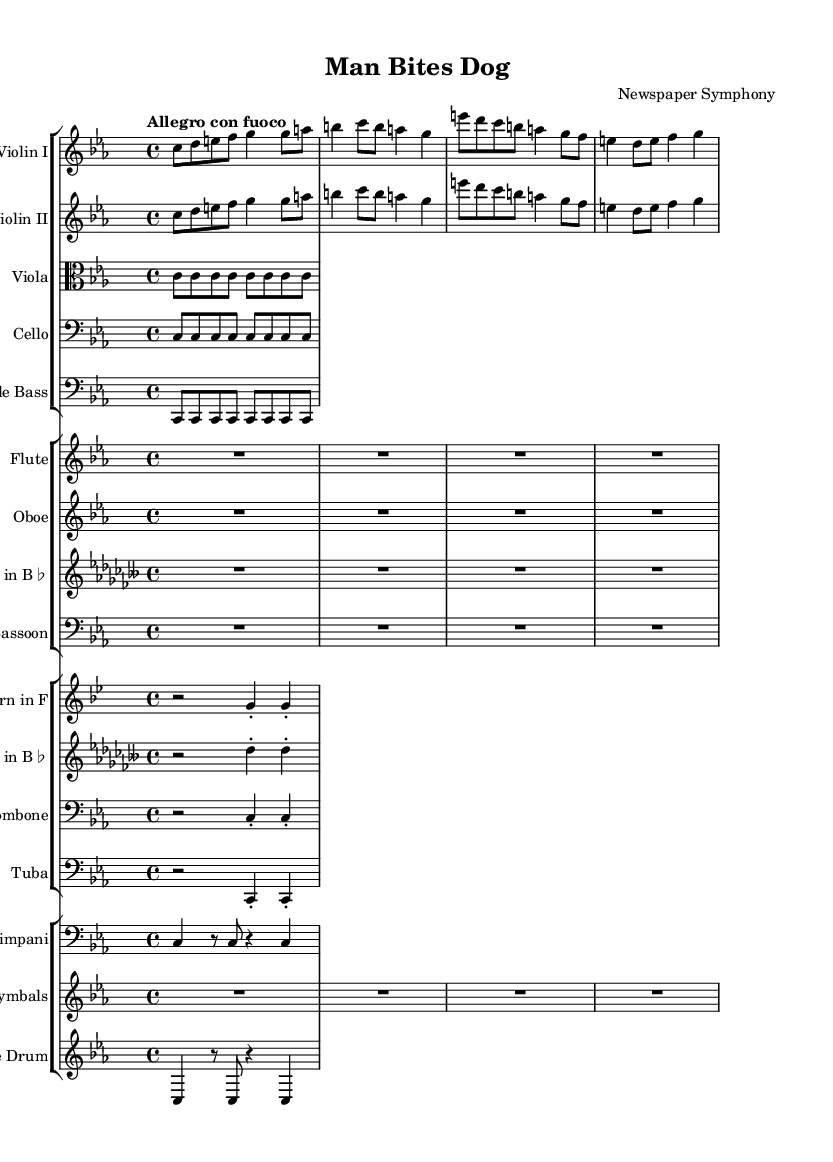what is the title of this music? The title is mentioned in the header section of the sheet music, specifically stated as "Man Bites Dog."
Answer: Man Bites Dog what is the key signature of this music? The key signature is indicated at the beginning of the global section with the command \key c \minor, which signifies C minor with three flats.
Answer: C minor what is the time signature of this music? The time signature is noted with \time 4/4 in the global section, indicating that there are four beats per measure and a quarter note receives one beat.
Answer: 4/4 what is the tempo marking for this piece? The tempo is described in the global section as "Allegro con fuoco," which specifies a fast tempo with energy.
Answer: Allegro con fuoco how many measures does the first violin part contain? By counting each measure in the violinOne notation, we see that there are a total of four measures presented within that part.
Answer: 4 which instruments play the same notes in this score? Examining the violinOne and violinTwo parts reveals they have identical pitches and rhythms throughout the measures, indicating they play the same notes.
Answer: Violin I and Violin II how many different instrument groups are represented in this score? The score consists of four separate staff groups: strings, woodwinds, brass, and percussion, as can be discerned from the separate sections created for each instrument type.
Answer: 4 